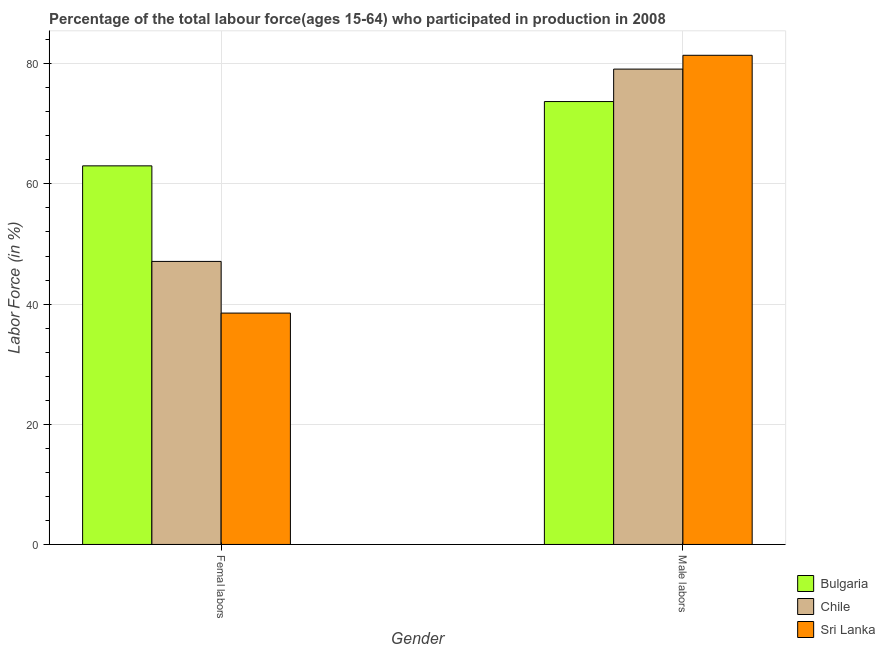How many groups of bars are there?
Offer a very short reply. 2. Are the number of bars on each tick of the X-axis equal?
Keep it short and to the point. Yes. What is the label of the 1st group of bars from the left?
Your answer should be compact. Femal labors. What is the percentage of female labor force in Sri Lanka?
Keep it short and to the point. 38.5. Across all countries, what is the maximum percentage of male labour force?
Offer a terse response. 81.4. Across all countries, what is the minimum percentage of female labor force?
Offer a very short reply. 38.5. In which country was the percentage of male labour force maximum?
Your answer should be very brief. Sri Lanka. In which country was the percentage of female labor force minimum?
Your response must be concise. Sri Lanka. What is the total percentage of female labor force in the graph?
Your answer should be very brief. 148.6. What is the difference between the percentage of male labour force in Bulgaria and that in Sri Lanka?
Provide a short and direct response. -7.7. What is the difference between the percentage of female labor force in Chile and the percentage of male labour force in Bulgaria?
Give a very brief answer. -26.6. What is the average percentage of male labour force per country?
Make the answer very short. 78.07. What is the difference between the percentage of male labour force and percentage of female labor force in Sri Lanka?
Make the answer very short. 42.9. In how many countries, is the percentage of male labour force greater than 32 %?
Your answer should be compact. 3. What is the ratio of the percentage of female labor force in Sri Lanka to that in Chile?
Provide a short and direct response. 0.82. Is the percentage of female labor force in Sri Lanka less than that in Bulgaria?
Offer a terse response. Yes. In how many countries, is the percentage of female labor force greater than the average percentage of female labor force taken over all countries?
Ensure brevity in your answer.  1. What does the 2nd bar from the right in Femal labors represents?
Keep it short and to the point. Chile. How many bars are there?
Your answer should be very brief. 6. Are all the bars in the graph horizontal?
Give a very brief answer. No. Does the graph contain any zero values?
Offer a terse response. No. Does the graph contain grids?
Offer a very short reply. Yes. Where does the legend appear in the graph?
Provide a succinct answer. Bottom right. How many legend labels are there?
Your answer should be compact. 3. What is the title of the graph?
Keep it short and to the point. Percentage of the total labour force(ages 15-64) who participated in production in 2008. Does "Egypt, Arab Rep." appear as one of the legend labels in the graph?
Provide a short and direct response. No. What is the label or title of the Y-axis?
Give a very brief answer. Labor Force (in %). What is the Labor Force (in %) in Bulgaria in Femal labors?
Provide a short and direct response. 63. What is the Labor Force (in %) of Chile in Femal labors?
Make the answer very short. 47.1. What is the Labor Force (in %) of Sri Lanka in Femal labors?
Provide a succinct answer. 38.5. What is the Labor Force (in %) of Bulgaria in Male labors?
Your answer should be very brief. 73.7. What is the Labor Force (in %) of Chile in Male labors?
Offer a terse response. 79.1. What is the Labor Force (in %) in Sri Lanka in Male labors?
Give a very brief answer. 81.4. Across all Gender, what is the maximum Labor Force (in %) of Bulgaria?
Offer a terse response. 73.7. Across all Gender, what is the maximum Labor Force (in %) of Chile?
Your answer should be compact. 79.1. Across all Gender, what is the maximum Labor Force (in %) of Sri Lanka?
Provide a short and direct response. 81.4. Across all Gender, what is the minimum Labor Force (in %) in Chile?
Provide a succinct answer. 47.1. Across all Gender, what is the minimum Labor Force (in %) in Sri Lanka?
Give a very brief answer. 38.5. What is the total Labor Force (in %) of Bulgaria in the graph?
Make the answer very short. 136.7. What is the total Labor Force (in %) of Chile in the graph?
Your answer should be compact. 126.2. What is the total Labor Force (in %) in Sri Lanka in the graph?
Your response must be concise. 119.9. What is the difference between the Labor Force (in %) in Bulgaria in Femal labors and that in Male labors?
Offer a terse response. -10.7. What is the difference between the Labor Force (in %) of Chile in Femal labors and that in Male labors?
Your response must be concise. -32. What is the difference between the Labor Force (in %) in Sri Lanka in Femal labors and that in Male labors?
Your response must be concise. -42.9. What is the difference between the Labor Force (in %) of Bulgaria in Femal labors and the Labor Force (in %) of Chile in Male labors?
Your answer should be very brief. -16.1. What is the difference between the Labor Force (in %) of Bulgaria in Femal labors and the Labor Force (in %) of Sri Lanka in Male labors?
Your answer should be compact. -18.4. What is the difference between the Labor Force (in %) of Chile in Femal labors and the Labor Force (in %) of Sri Lanka in Male labors?
Keep it short and to the point. -34.3. What is the average Labor Force (in %) of Bulgaria per Gender?
Your answer should be very brief. 68.35. What is the average Labor Force (in %) of Chile per Gender?
Give a very brief answer. 63.1. What is the average Labor Force (in %) of Sri Lanka per Gender?
Your answer should be very brief. 59.95. What is the difference between the Labor Force (in %) of Bulgaria and Labor Force (in %) of Sri Lanka in Femal labors?
Provide a succinct answer. 24.5. What is the difference between the Labor Force (in %) in Chile and Labor Force (in %) in Sri Lanka in Femal labors?
Make the answer very short. 8.6. What is the difference between the Labor Force (in %) of Bulgaria and Labor Force (in %) of Chile in Male labors?
Give a very brief answer. -5.4. What is the difference between the Labor Force (in %) of Bulgaria and Labor Force (in %) of Sri Lanka in Male labors?
Keep it short and to the point. -7.7. What is the ratio of the Labor Force (in %) in Bulgaria in Femal labors to that in Male labors?
Ensure brevity in your answer.  0.85. What is the ratio of the Labor Force (in %) in Chile in Femal labors to that in Male labors?
Provide a short and direct response. 0.6. What is the ratio of the Labor Force (in %) in Sri Lanka in Femal labors to that in Male labors?
Offer a terse response. 0.47. What is the difference between the highest and the second highest Labor Force (in %) of Sri Lanka?
Keep it short and to the point. 42.9. What is the difference between the highest and the lowest Labor Force (in %) in Chile?
Ensure brevity in your answer.  32. What is the difference between the highest and the lowest Labor Force (in %) of Sri Lanka?
Your answer should be compact. 42.9. 